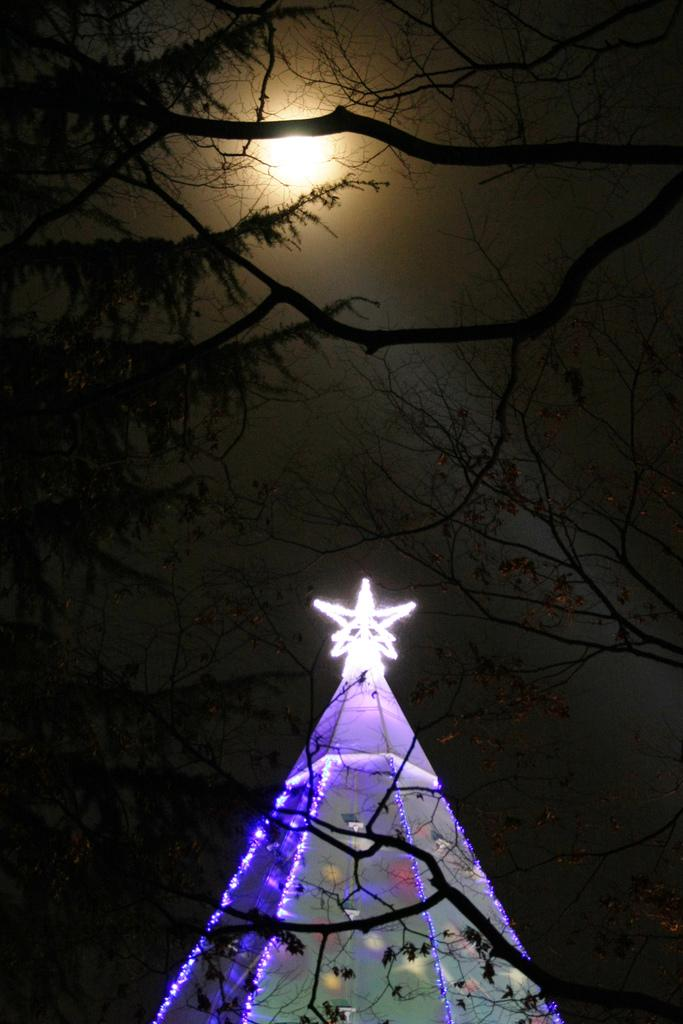What event is occurring in the image? There is a lightning strike in the image. What type of natural feature can be seen in the image? There are trees visible in the image. What celestial body is visible in the sky in the image? The moon is visible in the sky in the image. What type of hill can be seen in the image? There is no hill present in the image; it features a lightning strike, trees, and the moon. 